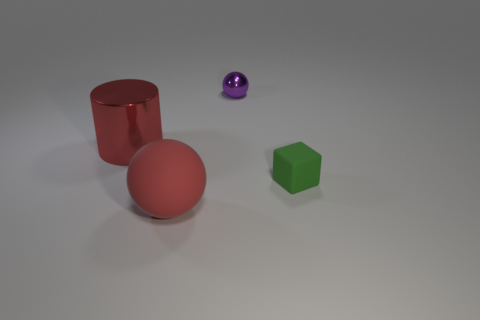How many objects are there in the image, and can you describe their shapes? There are four objects in the image. Starting from the left, there's a red cylinder, a red sphere, a purple sphere, and finally a green cube on the right. 